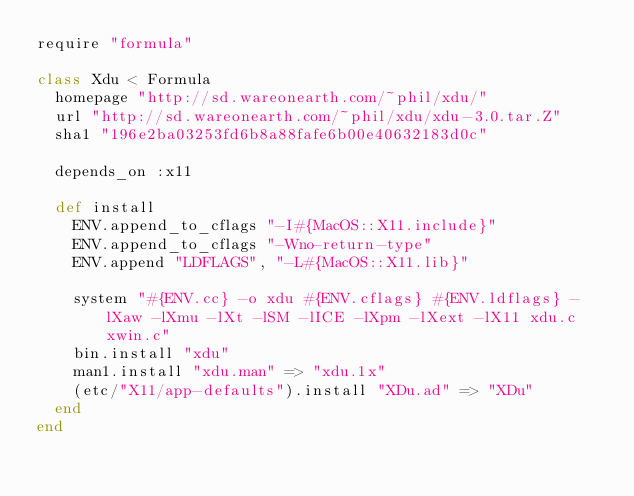Convert code to text. <code><loc_0><loc_0><loc_500><loc_500><_Ruby_>require "formula"

class Xdu < Formula
  homepage "http://sd.wareonearth.com/~phil/xdu/"
  url "http://sd.wareonearth.com/~phil/xdu/xdu-3.0.tar.Z"
  sha1 "196e2ba03253fd6b8a88fafe6b00e40632183d0c"

  depends_on :x11

  def install
    ENV.append_to_cflags "-I#{MacOS::X11.include}"
    ENV.append_to_cflags "-Wno-return-type"
    ENV.append "LDFLAGS", "-L#{MacOS::X11.lib}"

    system "#{ENV.cc} -o xdu #{ENV.cflags} #{ENV.ldflags} -lXaw -lXmu -lXt -lSM -lICE -lXpm -lXext -lX11 xdu.c xwin.c"
    bin.install "xdu"
    man1.install "xdu.man" => "xdu.1x"
    (etc/"X11/app-defaults").install "XDu.ad" => "XDu"
  end
end
</code> 